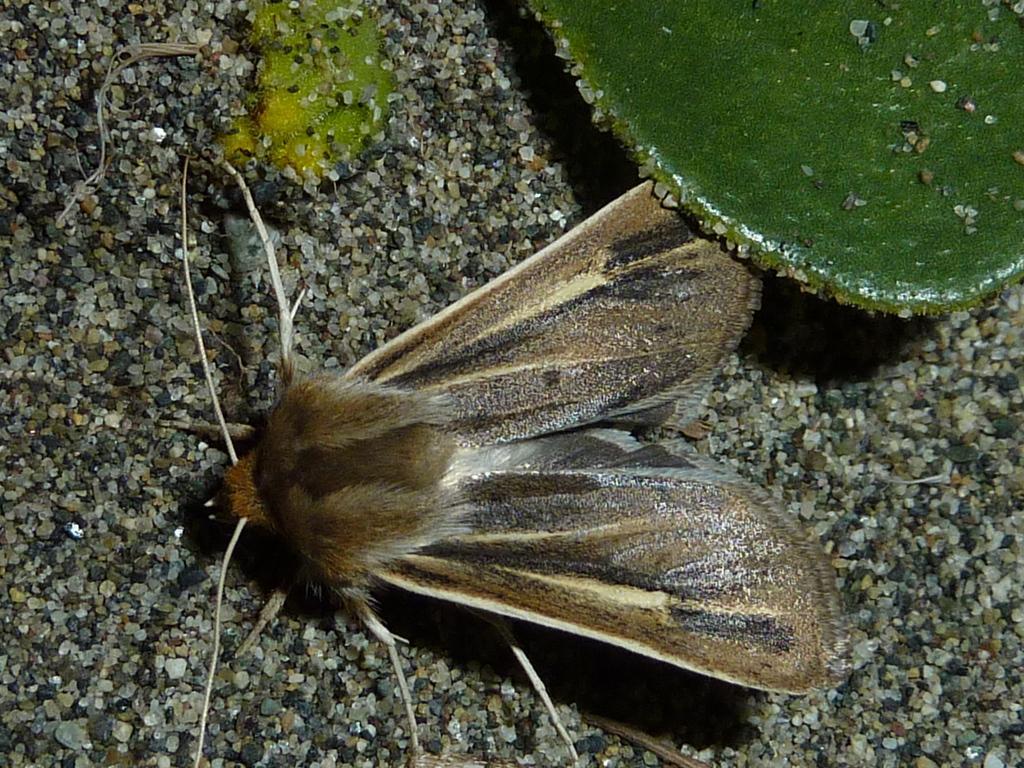Could you give a brief overview of what you see in this image? In the center of the image we can see a moth. In the top right corner we can see a leaf. In the background of the image we can see the stones. 